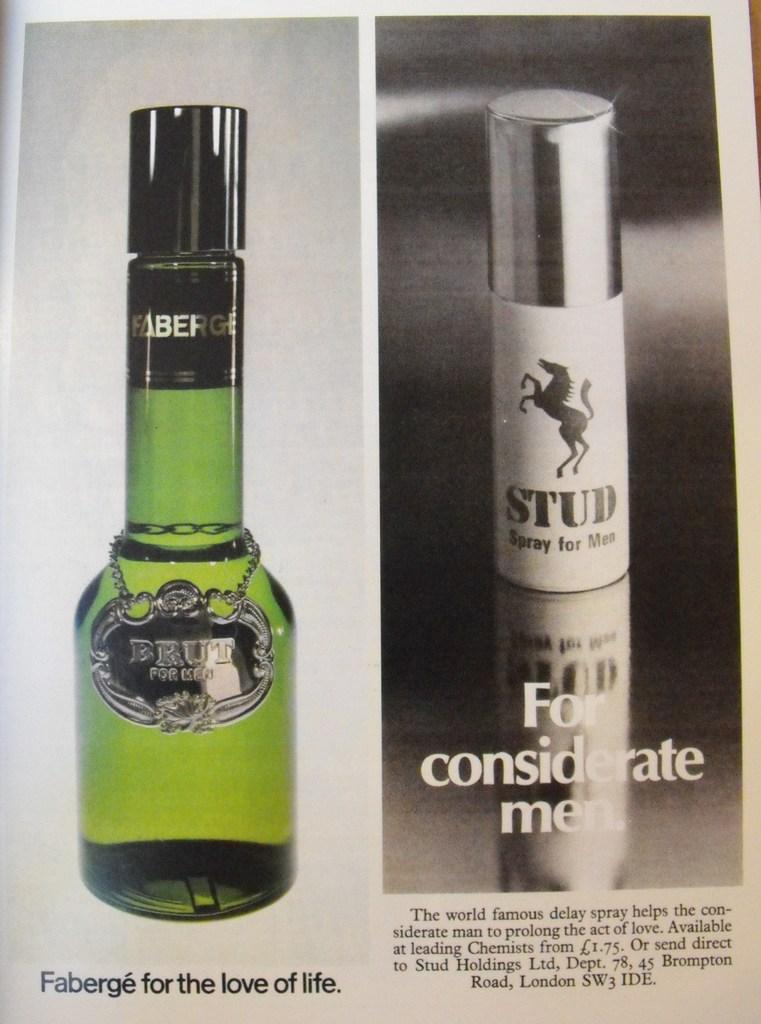<image>
Present a compact description of the photo's key features. a bottle of faberge brut and stud spray for men colonge 